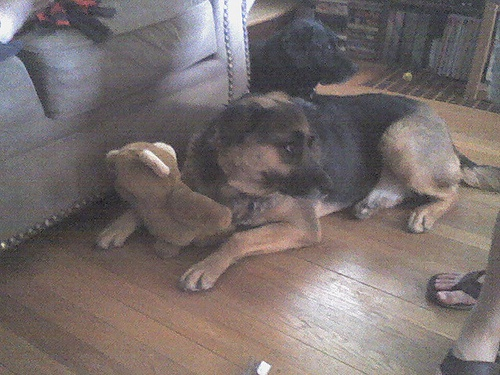Describe the objects in this image and their specific colors. I can see couch in gray and lightgray tones, dog in gray and darkgray tones, teddy bear in gray and darkgray tones, dog in gray and black tones, and people in gray and darkgray tones in this image. 